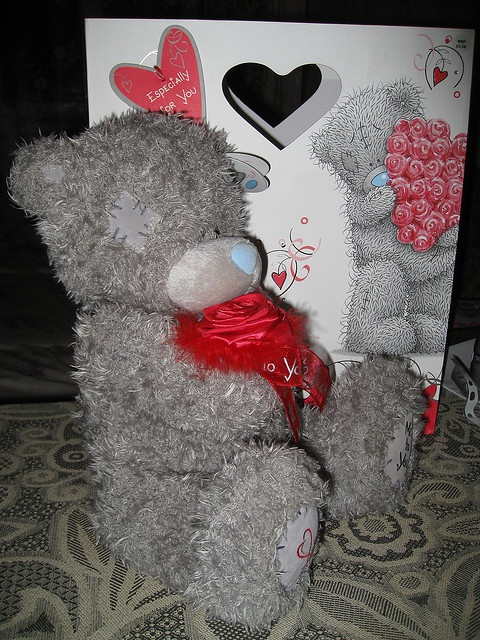Describe the objects in this image and their specific colors. I can see teddy bear in black, gray, darkgray, and brown tones and teddy bear in black, darkgray, gray, and lightgray tones in this image. 